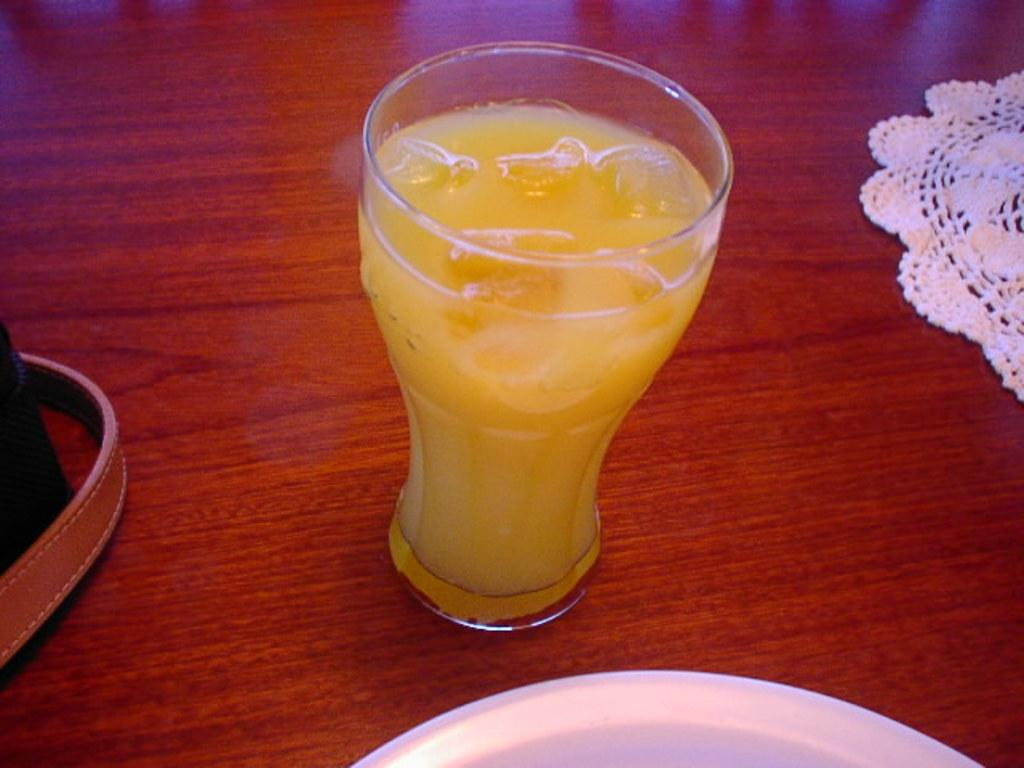What is in the glass that is visible in the image? There is a glass of juice in the image. What is added to the juice in the glass? The glass of juice contains ice cubes. What is the material of the table in the image? The table in the image appears to be made of wood. What is covering the table in the image? There is a cloth on the table. What other items are on the table in the image? There is a plate and another glass on the table. What type of fang can be seen in the image? There is no fang present in the image. What belief is being represented in the image? The image does not depict any specific beliefs. 